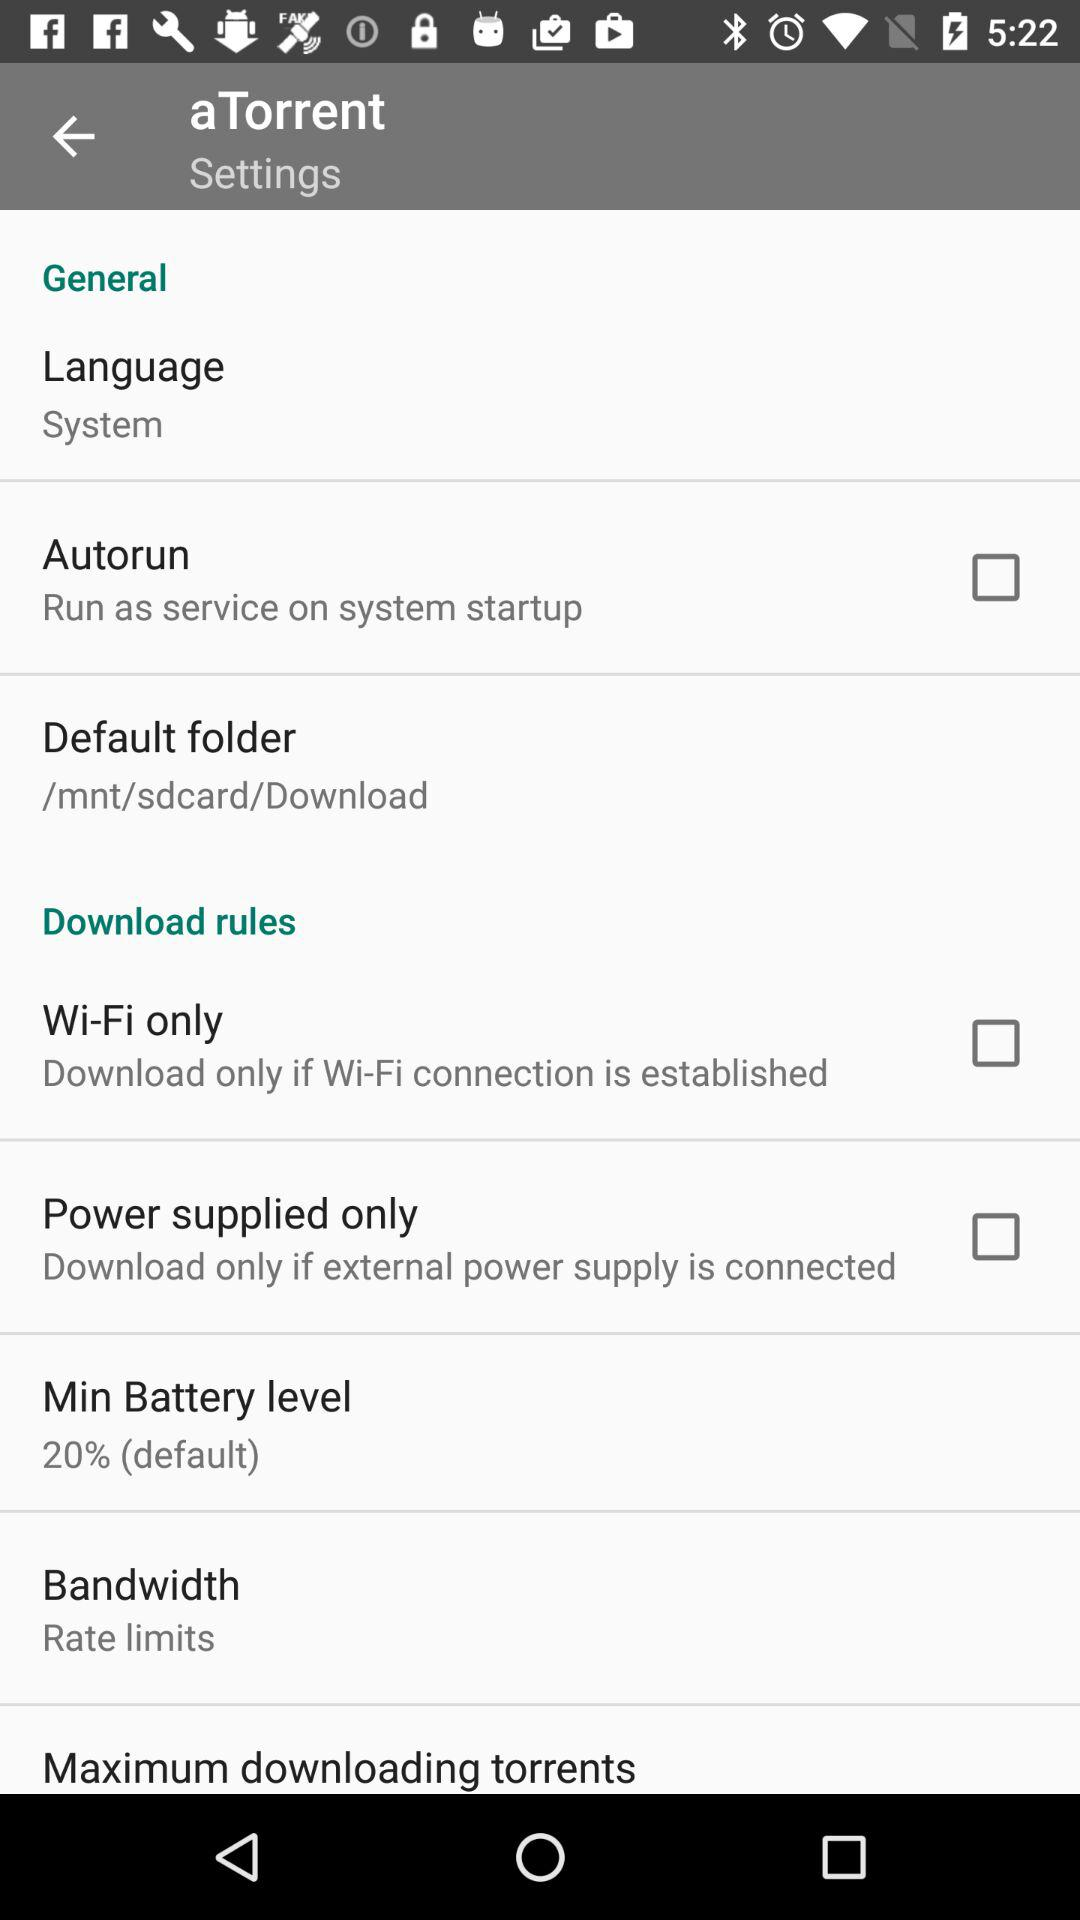What is the default download folder?
Answer the question using a single word or phrase. /mnt/sdcard/Download 